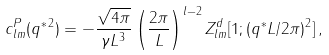Convert formula to latex. <formula><loc_0><loc_0><loc_500><loc_500>c ^ { P } _ { l m } ( q ^ { \ast \, 2 } ) = - \frac { \sqrt { 4 \pi } } { \gamma L ^ { 3 } } \left ( \frac { 2 \pi } { L } \right ) ^ { l - 2 } Z ^ { d } _ { l m } [ 1 ; ( q ^ { * } L / 2 \pi ) ^ { 2 } ] \, ,</formula> 